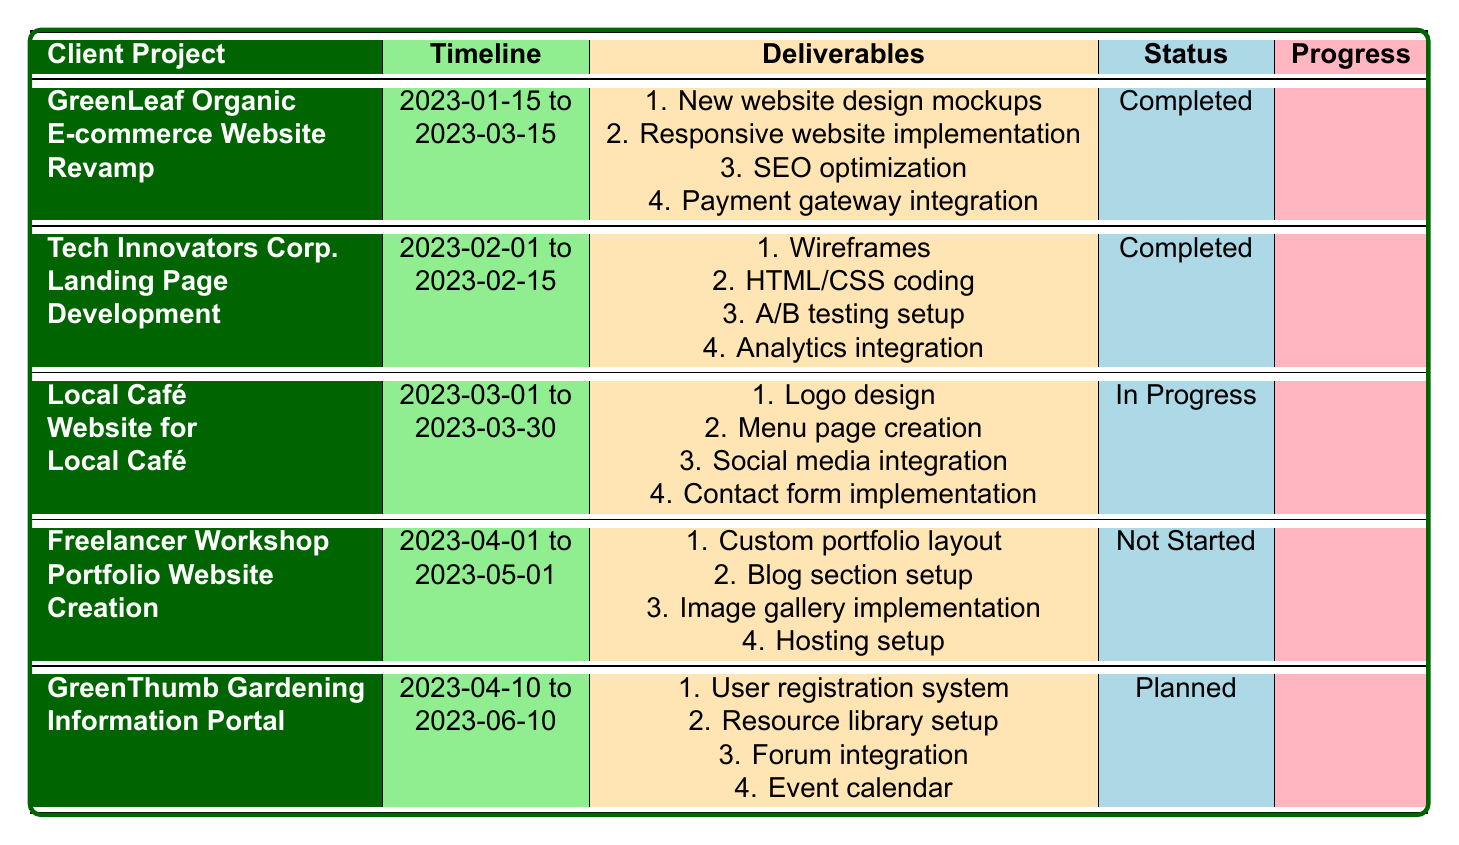What is the status of the "E-commerce Website Revamp" project? From the table, we can see the "E-commerce Website Revamp" project is listed under the client "GreenLeaf Organic," and its status is indicated in the "Status" column. Upon checking, it is marked as "Completed."
Answer: Completed How many deliverables are listed for the "Website for Local Café" project? The "Website for Local Café" project has several deliverables listed under the "Deliverables" column. Counting them, we find there are four deliverables: "Logo design," "Menu page creation," "Social media integration," and "Contact form implementation."
Answer: 4 Which project has the latest end date among all the listed projects? To find the project with the latest end date, we will review the "endDate" entries. The end dates are: March 15, February 15, March 30, May 1, and June 10. Comparing these dates, we see that "Information Portal" project under "GreenThumb Gardening" has the latest end date, which is June 10, 2023.
Answer: June 10, 2023 Are there any projects currently marked as "In Progress"? We can look for any projects in the table with the status "In Progress." The project listed with this status is "Website for Local Café." Therefore, the answer to this question is that yes, there is one project in progress.
Answer: Yes What is the time duration of the "Portfolio Website Creation" project in days? For calculating the duration of the "Portfolio Website Creation" project, we note the start date is April 1, 2023, and the end date is May 1, 2023. To find the duration, we can subtract the start date from the end date, resulting in 30 days.
Answer: 30 days How many projects have a status other than "Completed"? By examining the "Status" column for all listed projects, we find that there is one project marked as "In Progress" and one as "Planned." Thus, there are two projects with a status other than "Completed."
Answer: 2 Which client has the project that ends first among those with a “Completed” status? The table shows that two projects are marked as "Completed": "E-commerce Website Revamp" ends on March 15, 2023, and "Landing Page Development" ends on February 15, 2023. Comparing these, the "Landing Page Development" project ends first.
Answer: Tech Innovators Corp 